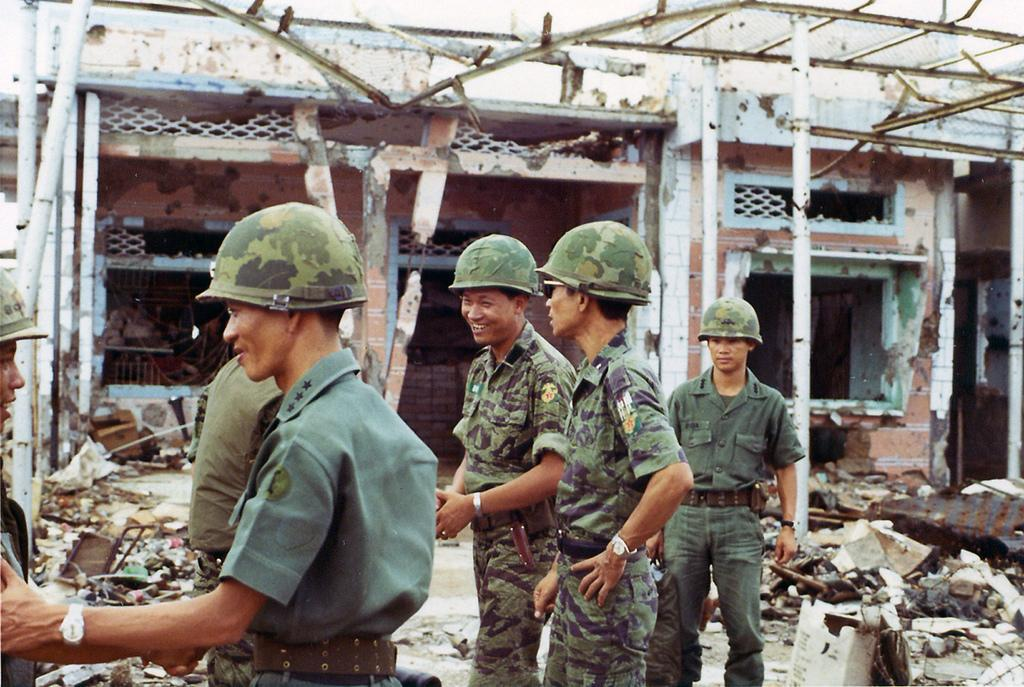What is the condition of the house in the image? The house in the image is demolished. What else can be seen in the image besides the demolished house? There are soldiers standing in the image. What is the opinion of the trains in the image? There are no trains present in the image, so it is not possible to determine their opinion. 